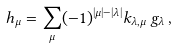<formula> <loc_0><loc_0><loc_500><loc_500>h _ { \mu } & = \sum _ { \mu } ( - 1 ) ^ { | \mu | - | \lambda | } k _ { \lambda , \mu } \, g _ { \lambda } \, ,</formula> 